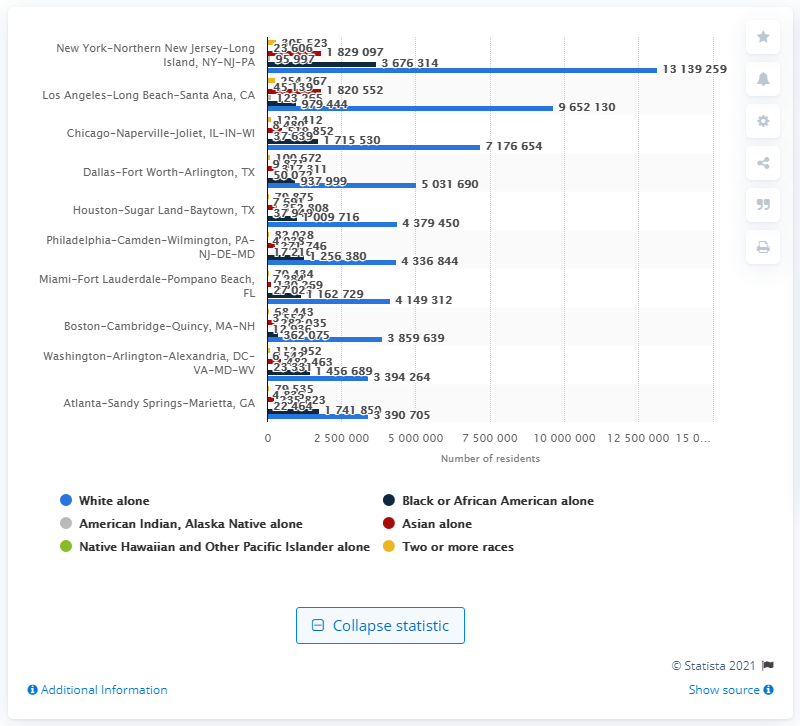Give some essential details in this illustration. In 2009, there were approximately 1,829,097 individuals of Asian ethnicity residing in New York. 